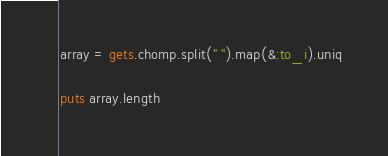Convert code to text. <code><loc_0><loc_0><loc_500><loc_500><_Ruby_>array = gets.chomp.split(" ").map(&:to_i).uniq

puts array.length

</code> 